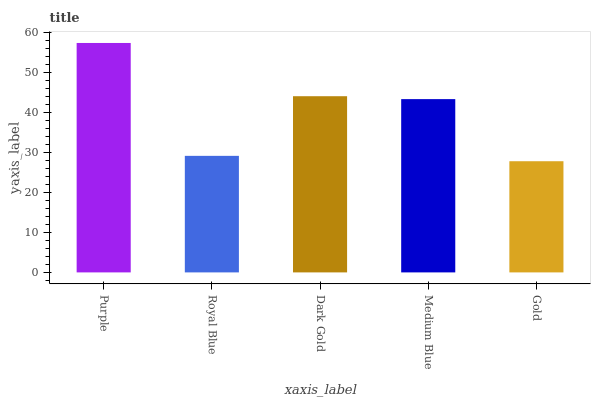Is Royal Blue the minimum?
Answer yes or no. No. Is Royal Blue the maximum?
Answer yes or no. No. Is Purple greater than Royal Blue?
Answer yes or no. Yes. Is Royal Blue less than Purple?
Answer yes or no. Yes. Is Royal Blue greater than Purple?
Answer yes or no. No. Is Purple less than Royal Blue?
Answer yes or no. No. Is Medium Blue the high median?
Answer yes or no. Yes. Is Medium Blue the low median?
Answer yes or no. Yes. Is Dark Gold the high median?
Answer yes or no. No. Is Purple the low median?
Answer yes or no. No. 